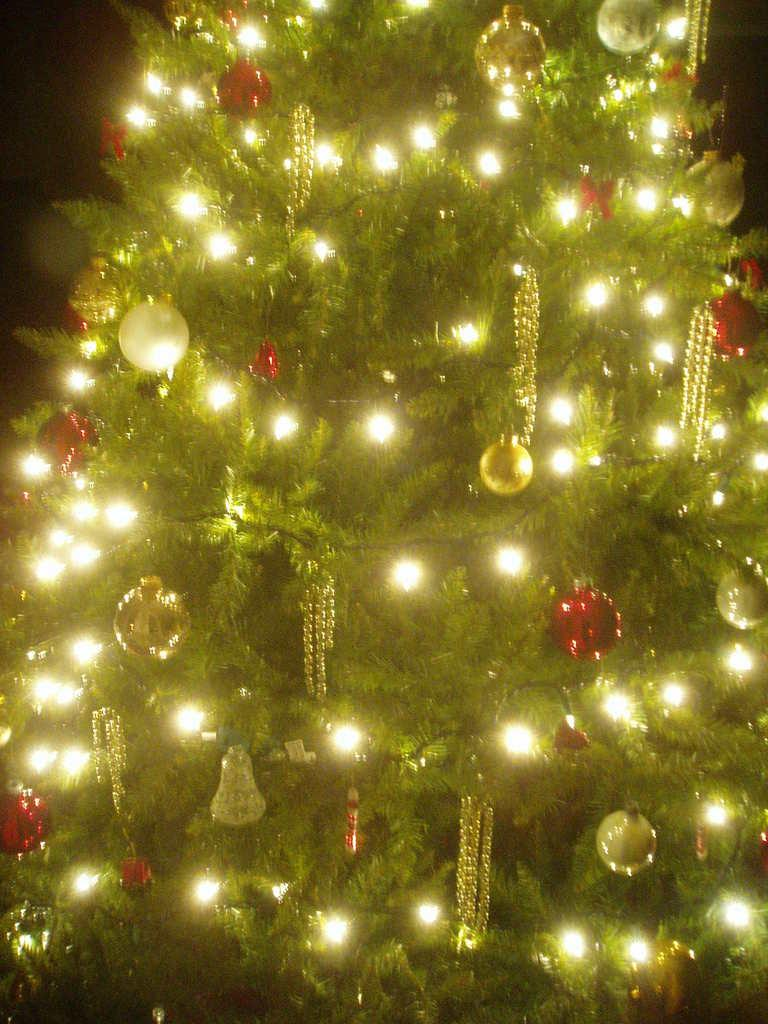What is the main object in the image? There is a Christmas tree in the image. What decorations can be seen on the Christmas tree? The Christmas tree has lights and balls attached to it. Are there any other decorations on the Christmas tree besides lights and balls? Yes, there are other unspecified things attached to the Christmas tree. What type of agreement is being discussed by the actors in the image? There are no actors present in the image, and therefore no discussion of agreements can be observed. 